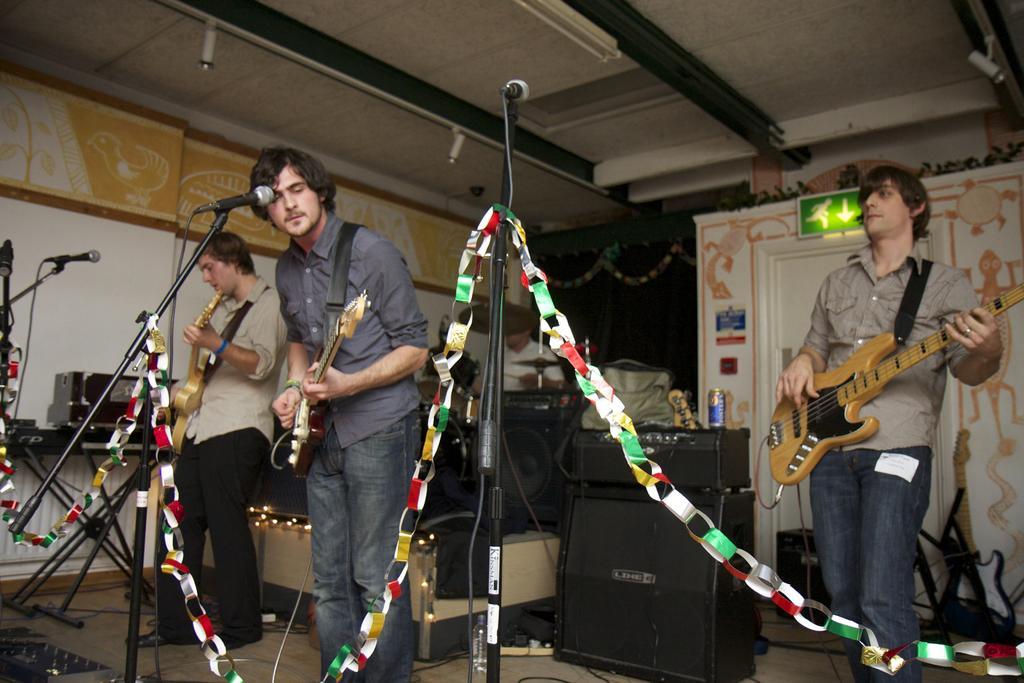Please provide a concise description of this image. In this image I can see three men are playing guitar in front of a microphone. 